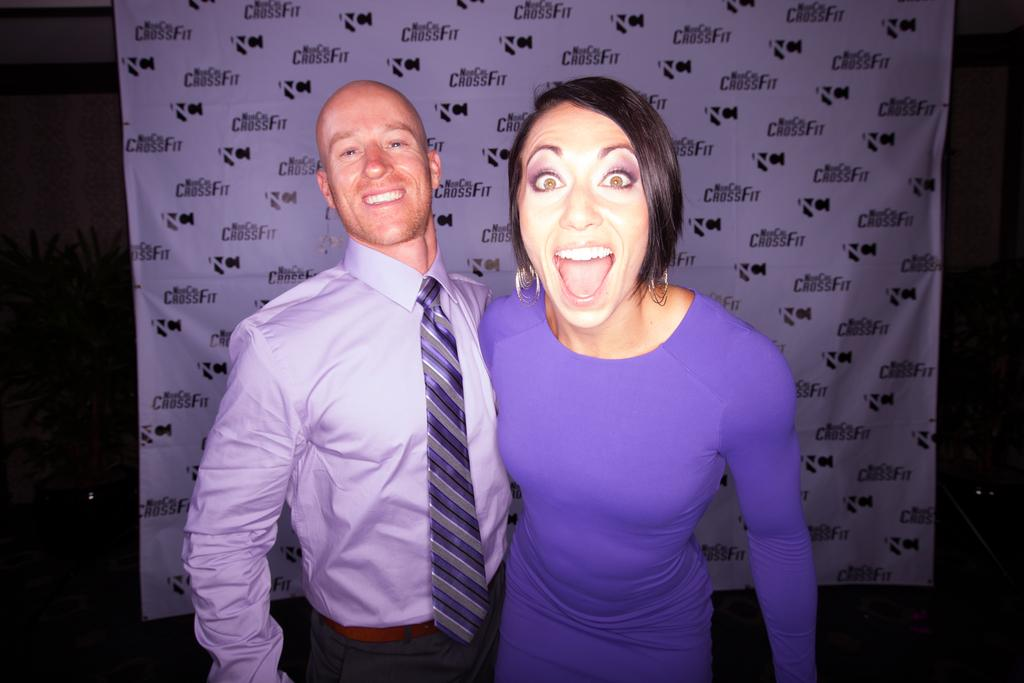How many people are in the image? There are two persons standing in the image. What is the surface on which the persons are standing? The persons are standing on the floor. What can be seen behind the persons in the image? There is a banner behind the persons. What type of vegetation is visible in the background of the image? There are plants visible in the background of the image. What type of hen can be seen twisting around the persons in the image? There is no hen present in the image, and therefore no such activity can be observed. 